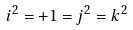<formula> <loc_0><loc_0><loc_500><loc_500>i ^ { 2 } = + 1 = j ^ { 2 } = k ^ { 2 }</formula> 